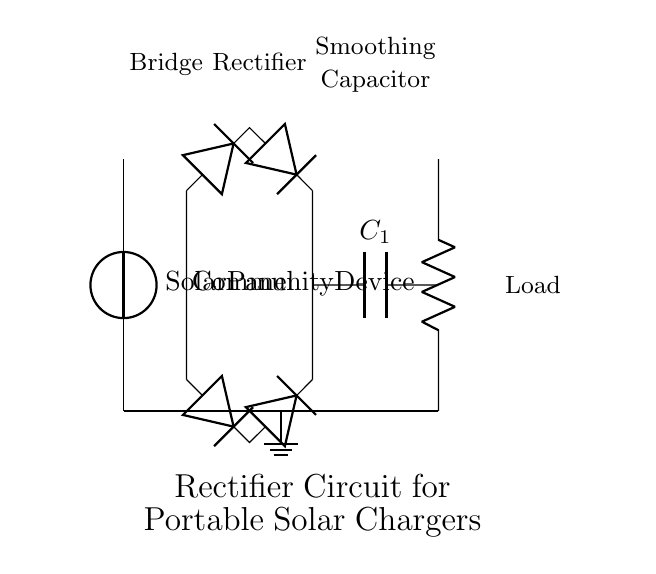What type of diodes are used in this circuit? The circuit diagram shows a bridge rectifier configuration, which typically uses four diodes connected in a specific arrangement. Since only two diodes are shown, we can conclude that the type is standard silicon diodes.
Answer: silicon diodes What component is used to smooth the output voltage? The circuit includes a capacitor labeled C1, which is used to reduce voltage fluctuations by storing charge and releasing it slowly, thus smoothing the output voltage.
Answer: Capacitor How many diodes are present in the rectifier? In the bridge rectifier configuration, there are four diodes. Even though only two are depicted directly, in a complete bridge configuration, four are used to ensure current flows correctly.
Answer: four What is the load being powered in this circuit? The load labeled as "Community Device" indicates that this circuit is intended to supply power to a portable device that serves community outreach purposes.
Answer: Community Device What is the function of the solar panel in this circuit? The solar panel serves as the source of renewable energy, converting sunlight into electrical energy for the circuit. It connects to the voltage source at the beginning of the diagram.
Answer: Power source How does the capacitor improve circuit performance? The capacitor acts as a smoothing device that stores energy and releases it gradually, helping to reduce voltage ripples that result from the rectification process, thus providing a more stable voltage to the load.
Answer: Stabilizes voltage What configuration is used for the rectifier in this circuit? The diagram shows a bridge rectifier configuration, which consists of four diodes arranged in a bridge to efficiently convert AC to DC, making it suitable for charging applications.
Answer: Bridge rectifier 